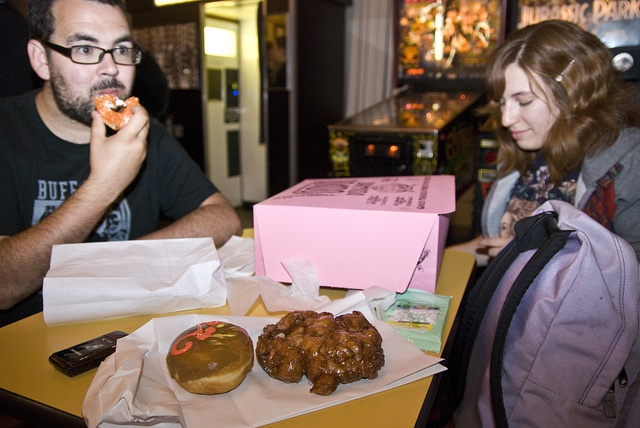Describe the objects in this image and their specific colors. I can see dining table in black, lavender, darkgray, olive, and pink tones, people in black, tan, and gray tones, backpack in black, gray, and darkgray tones, people in black, gray, and maroon tones, and donut in black, maroon, olive, and tan tones in this image. 